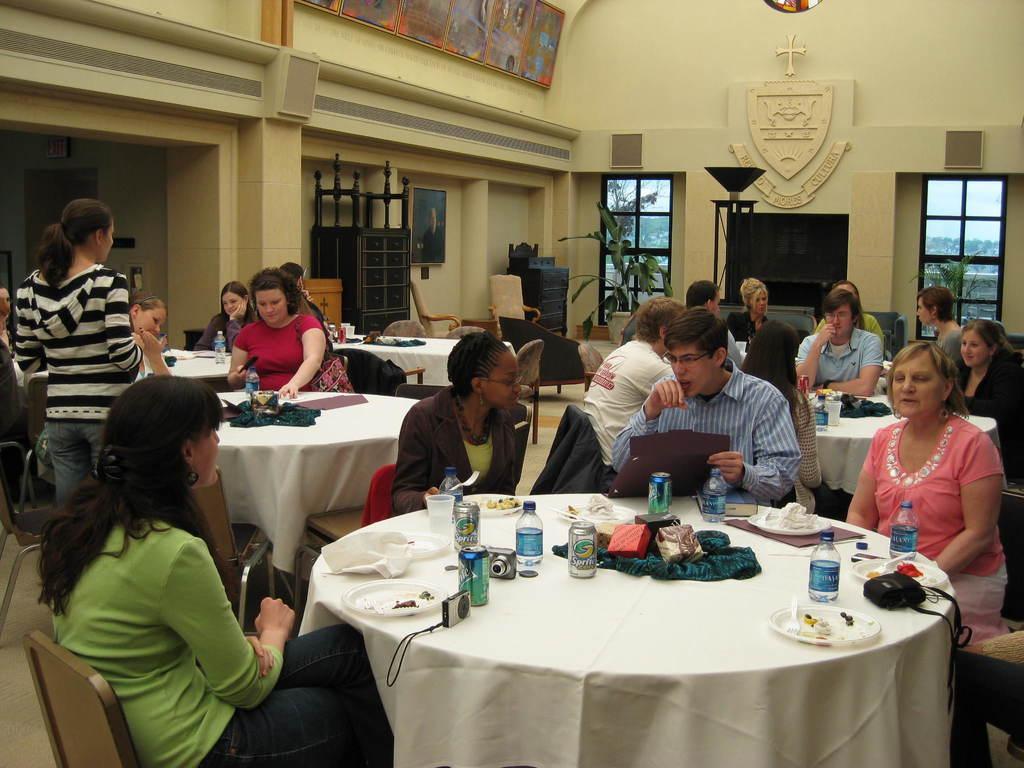Please provide a concise description of this image. There is a group of people. They are sitting on chairs. On the left side of the person is standing. There is a table. There is a glass,plate,cloth,bottle on a table. We can see in the background wall,TV,posters,shield. 